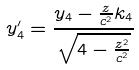<formula> <loc_0><loc_0><loc_500><loc_500>y _ { 4 } ^ { \prime } = \frac { y _ { 4 } - \frac { z } { c ^ { 2 } } k _ { 4 } } { \sqrt { 4 - \frac { z ^ { 2 } } { c ^ { 2 } } } }</formula> 